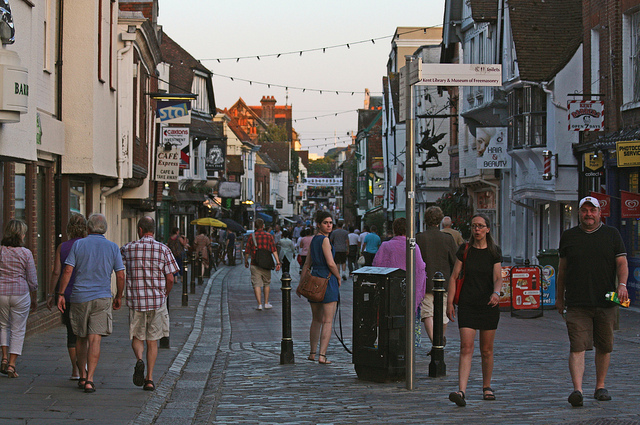Are there any notable architectural styles or historical elements visible in this area? The buildings along the street exhibit traditional architectural features, with façades that suggest a mixture of historical periods. Notably, there is varied roofline heights and shapes, indicative of development over time. The cobbled street itself is a historical element, hinting at the preservation of older urban designs in the town. 